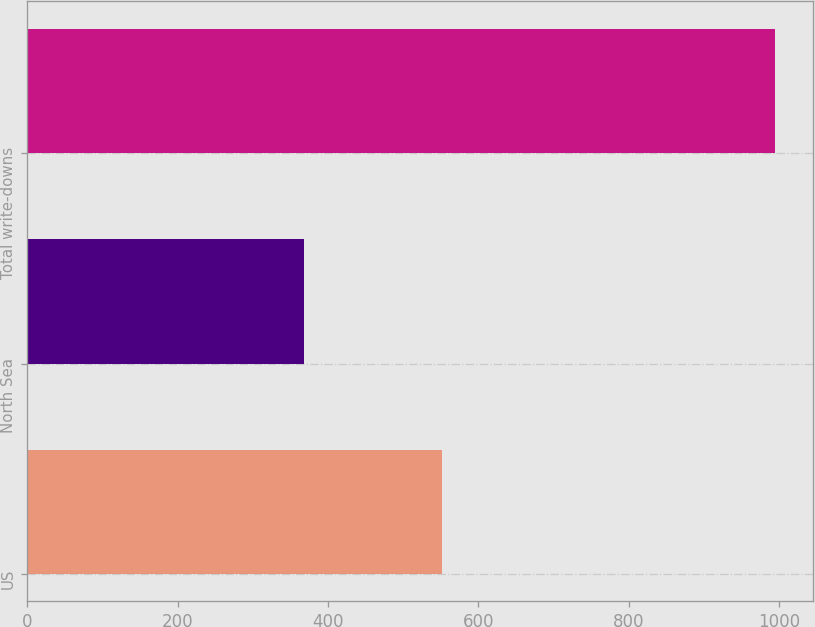Convert chart. <chart><loc_0><loc_0><loc_500><loc_500><bar_chart><fcel>US<fcel>North Sea<fcel>Total write-downs<nl><fcel>552<fcel>368<fcel>995<nl></chart> 